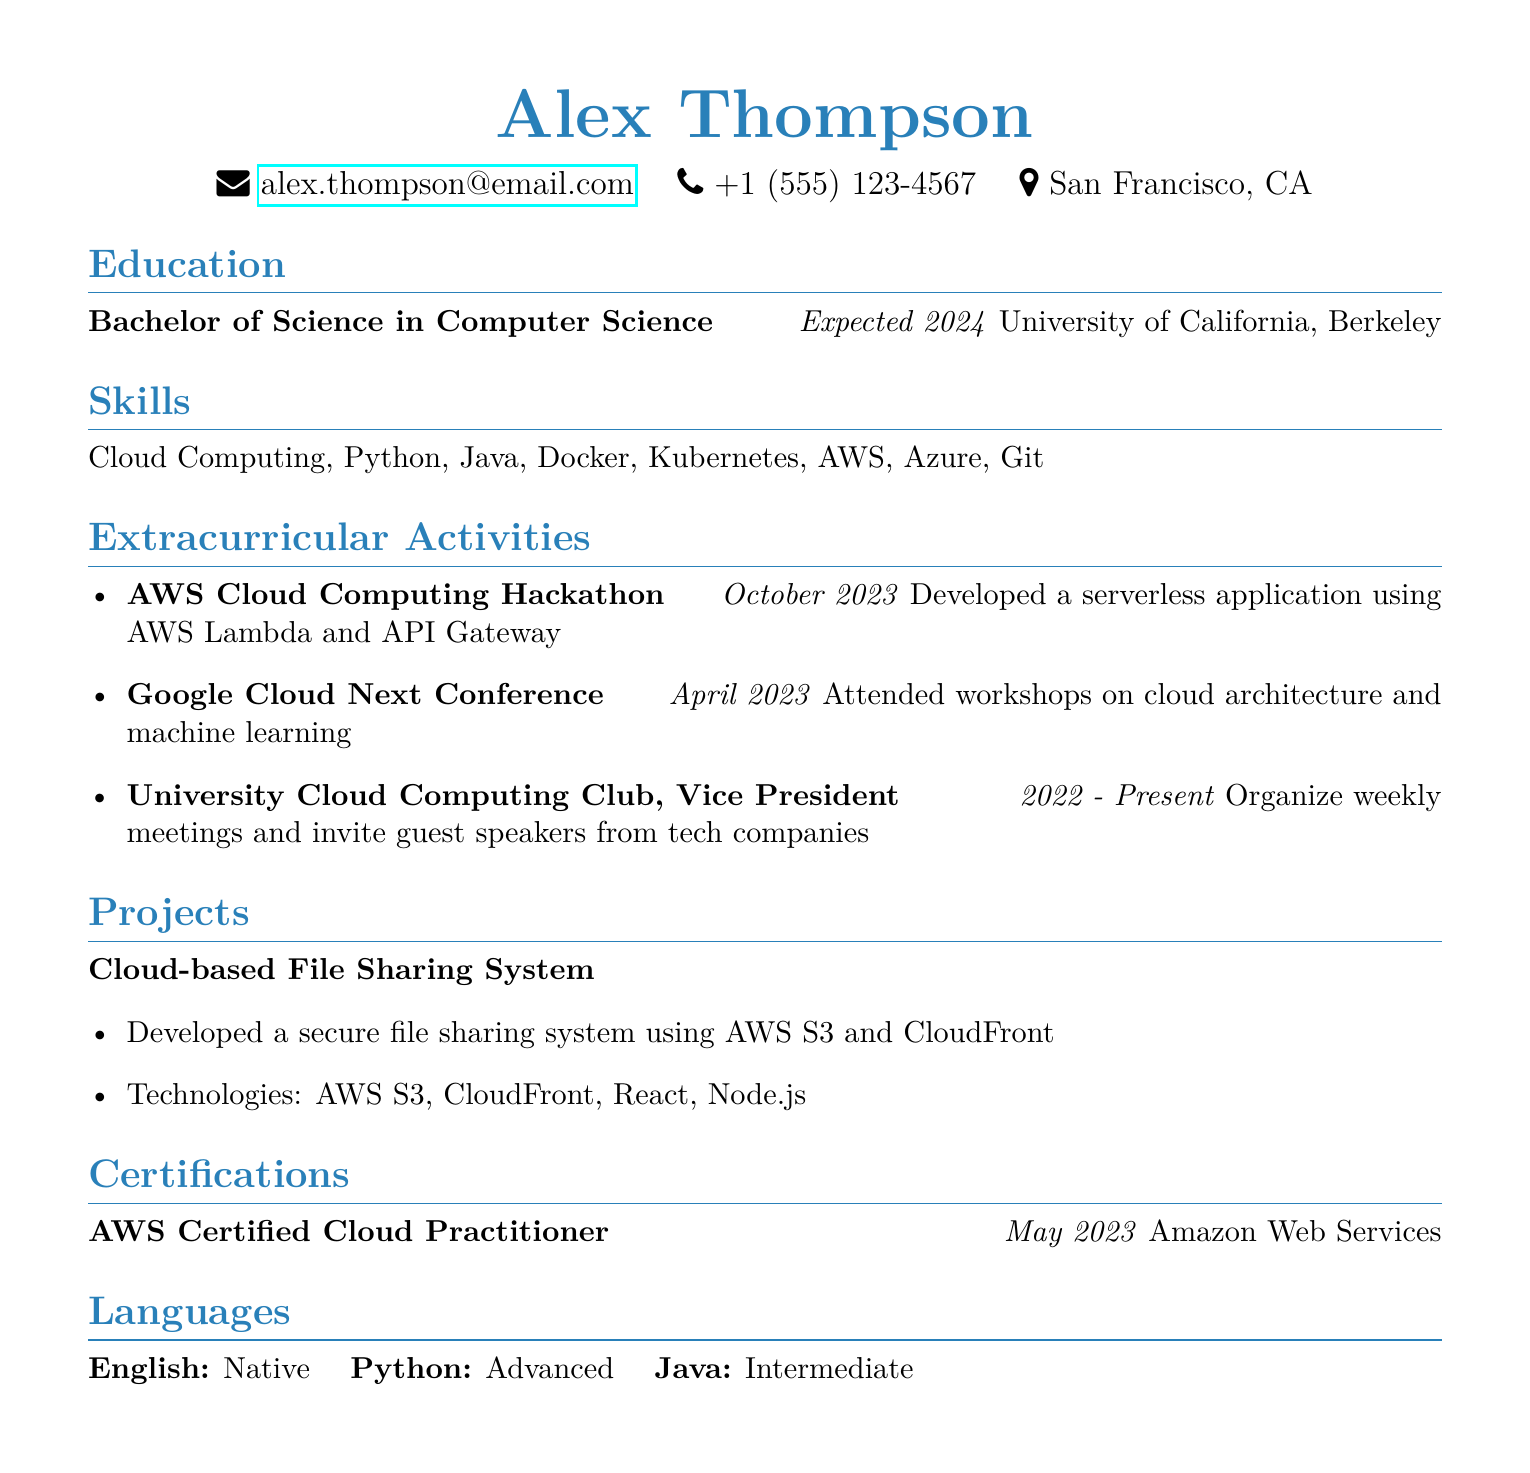what is the name of the individual? The name of the individual is prominently displayed at the top of the document as Alex Thompson.
Answer: Alex Thompson what is the degree pursued by the candidate? The degree is stated under the Education section, which mentions Bachelor of Science in Computer Science.
Answer: Bachelor of Science in Computer Science what role did the individual have in the University Cloud Computing Club? The individual's role is explicitly mentioned in the extracurricular activities section as Vice President.
Answer: Vice President when is the expected graduation year? This information is included under the Education section as expected 2024.
Answer: 2024 which cloud computing platform was used in the hackathon project? The document details that AWS Lambda and API Gateway were utilized in the hackathon project.
Answer: AWS Lambda how many certifications are listed in the document? The document contains one certification under the Certifications section.
Answer: 1 what is the name of the hackathon participation event? The event name is listed in the extracurricular activities section as AWS Cloud Computing Hackathon.
Answer: AWS Cloud Computing Hackathon how long has the individual been vice president of the Cloud Computing Club? The tenure is specified in the document as 2022 to Present, indicating a span from 2022 until now.
Answer: 2022 - Present what technologies were used in the cloud-based file sharing system project? The technologies used are explicitly mentioned in the Projects section, which lists AWS S3, CloudFront, React, and Node.js.
Answer: AWS S3, CloudFront, React, Node.js 